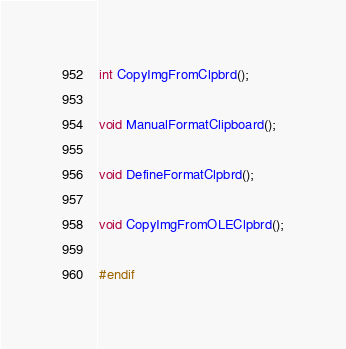<code> <loc_0><loc_0><loc_500><loc_500><_C_>
int CopyImgFromClpbrd();

void ManualFormatClipboard();

void DefineFormatClpbrd();

void CopyImgFromOLEClpbrd();

#endif</code> 